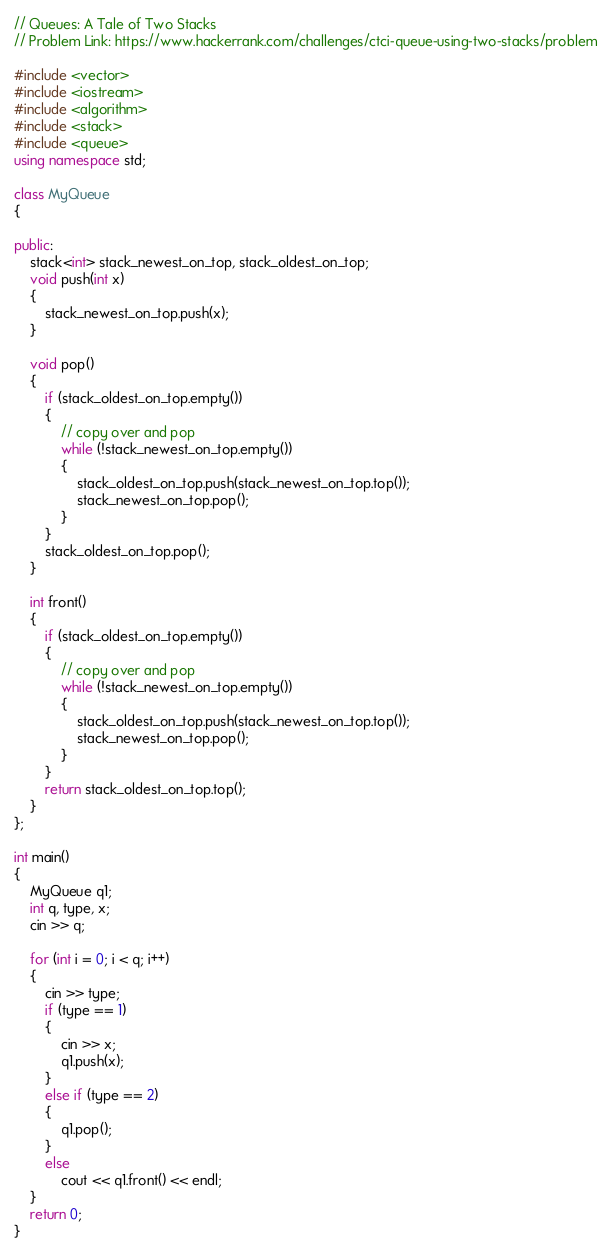<code> <loc_0><loc_0><loc_500><loc_500><_C++_>// Queues: A Tale of Two Stacks
// Problem Link: https://www.hackerrank.com/challenges/ctci-queue-using-two-stacks/problem

#include <vector>
#include <iostream>
#include <algorithm>
#include <stack>
#include <queue>
using namespace std;

class MyQueue
{

public:
    stack<int> stack_newest_on_top, stack_oldest_on_top;
    void push(int x)
    {
        stack_newest_on_top.push(x);
    }

    void pop()
    {
        if (stack_oldest_on_top.empty())
        {
            // copy over and pop
            while (!stack_newest_on_top.empty())
            {
                stack_oldest_on_top.push(stack_newest_on_top.top());
                stack_newest_on_top.pop();
            }
        }
        stack_oldest_on_top.pop();
    }

    int front()
    {
        if (stack_oldest_on_top.empty())
        {
            // copy over and pop
            while (!stack_newest_on_top.empty())
            {
                stack_oldest_on_top.push(stack_newest_on_top.top());
                stack_newest_on_top.pop();
            }
        }
        return stack_oldest_on_top.top();
    }
};

int main()
{
    MyQueue q1;
    int q, type, x;
    cin >> q;

    for (int i = 0; i < q; i++)
    {
        cin >> type;
        if (type == 1)
        {
            cin >> x;
            q1.push(x);
        }
        else if (type == 2)
        {
            q1.pop();
        }
        else
            cout << q1.front() << endl;
    }
    return 0;
}</code> 